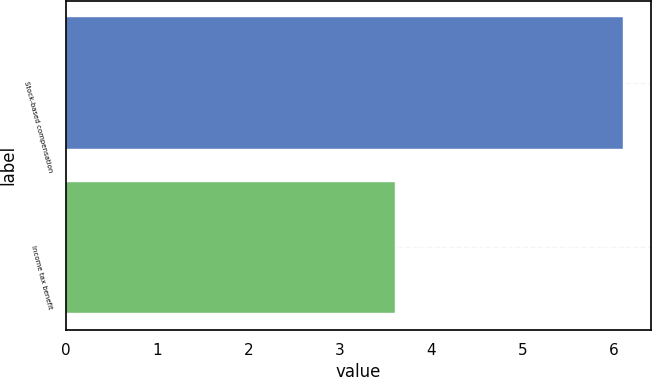<chart> <loc_0><loc_0><loc_500><loc_500><bar_chart><fcel>Stock-based compensation<fcel>Income tax benefit<nl><fcel>6.1<fcel>3.6<nl></chart> 